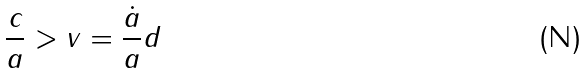<formula> <loc_0><loc_0><loc_500><loc_500>\frac { c } { a } > v = \frac { \dot { a } } { a } d</formula> 